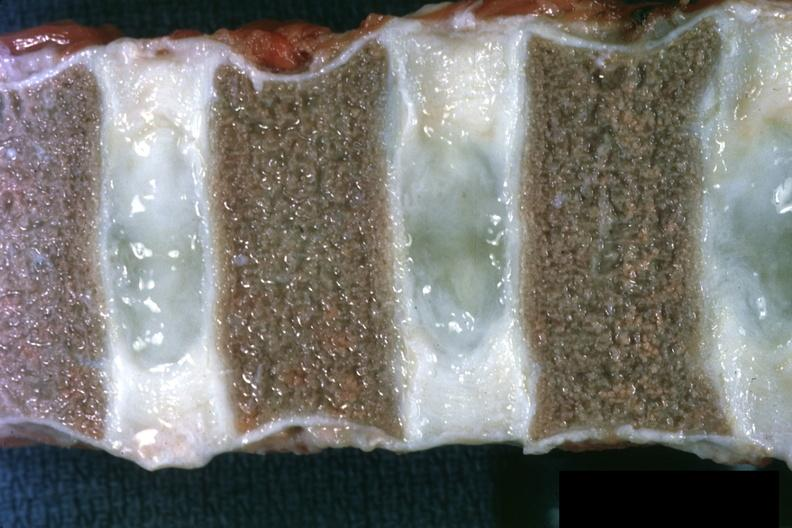what entered into this file as normal discs slide?
Answer the question using a single word or phrase. Close-up view of vertebral marrow not too spectacular are well shown and 